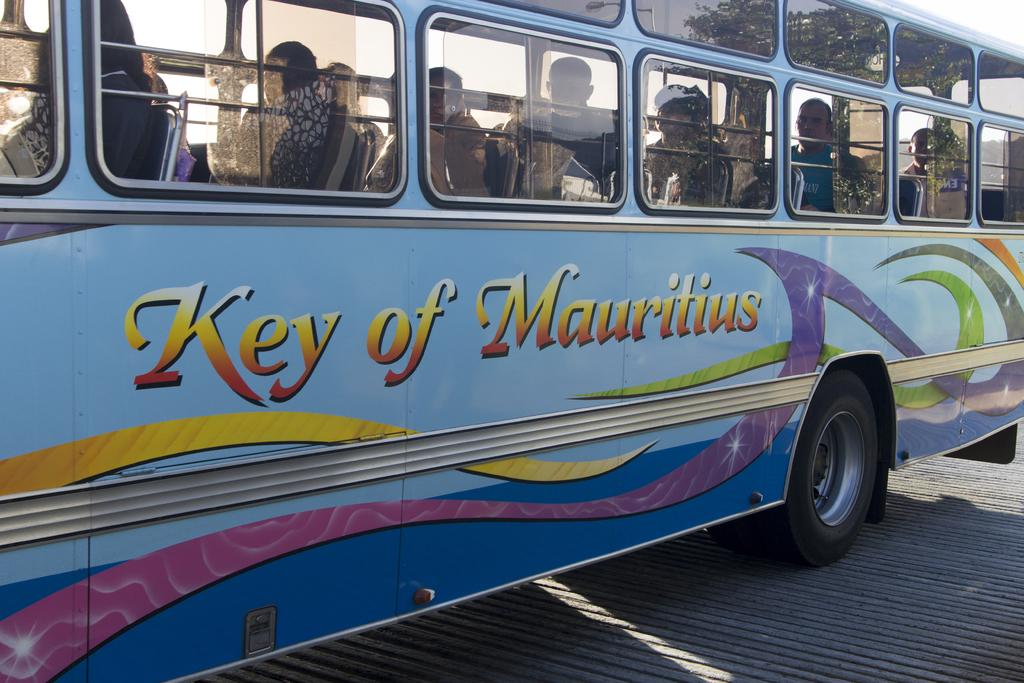What is the main subject in the foreground of the image? There is a bus in the foreground of the image. What are the people inside the bus doing? People are sitting inside the bus. What can be seen in the background of the image? There are trees and the sky visible in the background of the image. What decorative elements are present on the bus? There is a colorful painting and text on the bus. What type of bun is being served to the passengers on the bus? There is no bun present in the image; it features a bus with people sitting inside. Are the passengers wearing suits while riding the bus? The image does not provide information about the passengers' clothing, so it cannot be determined if they are wearing suits. 